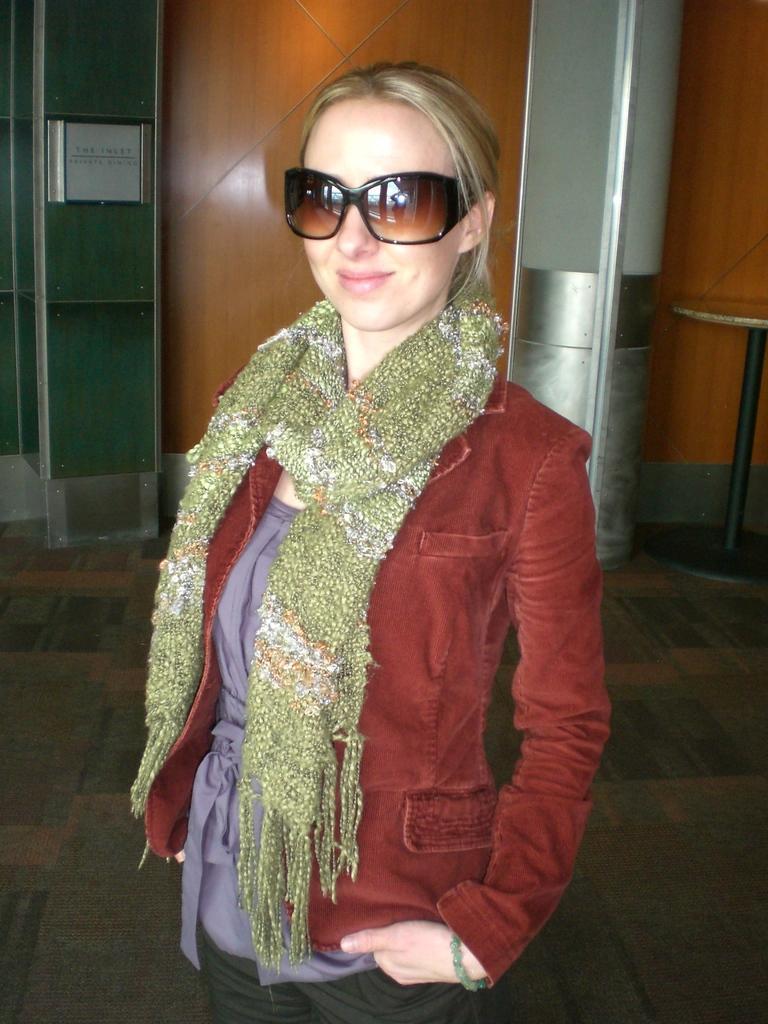Can you describe this image briefly? In the picture I can see a woman standing and smiling. 